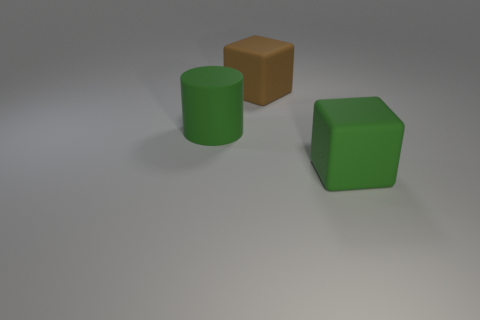Add 2 brown shiny blocks. How many objects exist? 5 Subtract all cylinders. How many objects are left? 2 Add 1 small cyan matte balls. How many small cyan matte balls exist? 1 Subtract 0 purple cylinders. How many objects are left? 3 Subtract all small gray rubber balls. Subtract all big green things. How many objects are left? 1 Add 2 large brown matte objects. How many large brown matte objects are left? 3 